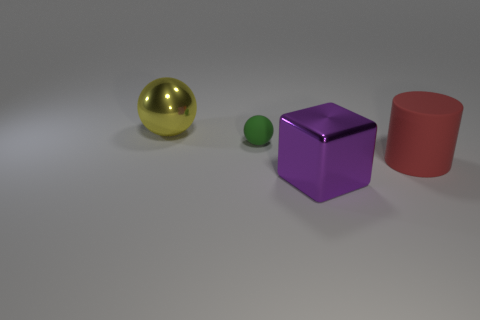Is the number of big metallic cubes behind the purple thing less than the number of small green spheres in front of the large yellow metallic sphere?
Your answer should be compact. Yes. Does the big matte object have the same shape as the green matte object?
Provide a short and direct response. No. How many other things are there of the same size as the green rubber object?
Offer a terse response. 0. How many objects are metal things that are in front of the big yellow ball or objects behind the purple metallic object?
Offer a terse response. 4. What number of other big yellow metallic objects have the same shape as the big yellow shiny object?
Provide a short and direct response. 0. There is a object that is both behind the large purple object and to the right of the tiny green ball; what material is it made of?
Offer a terse response. Rubber. How many green objects are behind the matte cylinder?
Ensure brevity in your answer.  1. How many shiny objects are there?
Make the answer very short. 2. Is the size of the block the same as the red cylinder?
Give a very brief answer. Yes. Is there a shiny cube in front of the thing that is right of the shiny thing right of the tiny green sphere?
Give a very brief answer. Yes. 